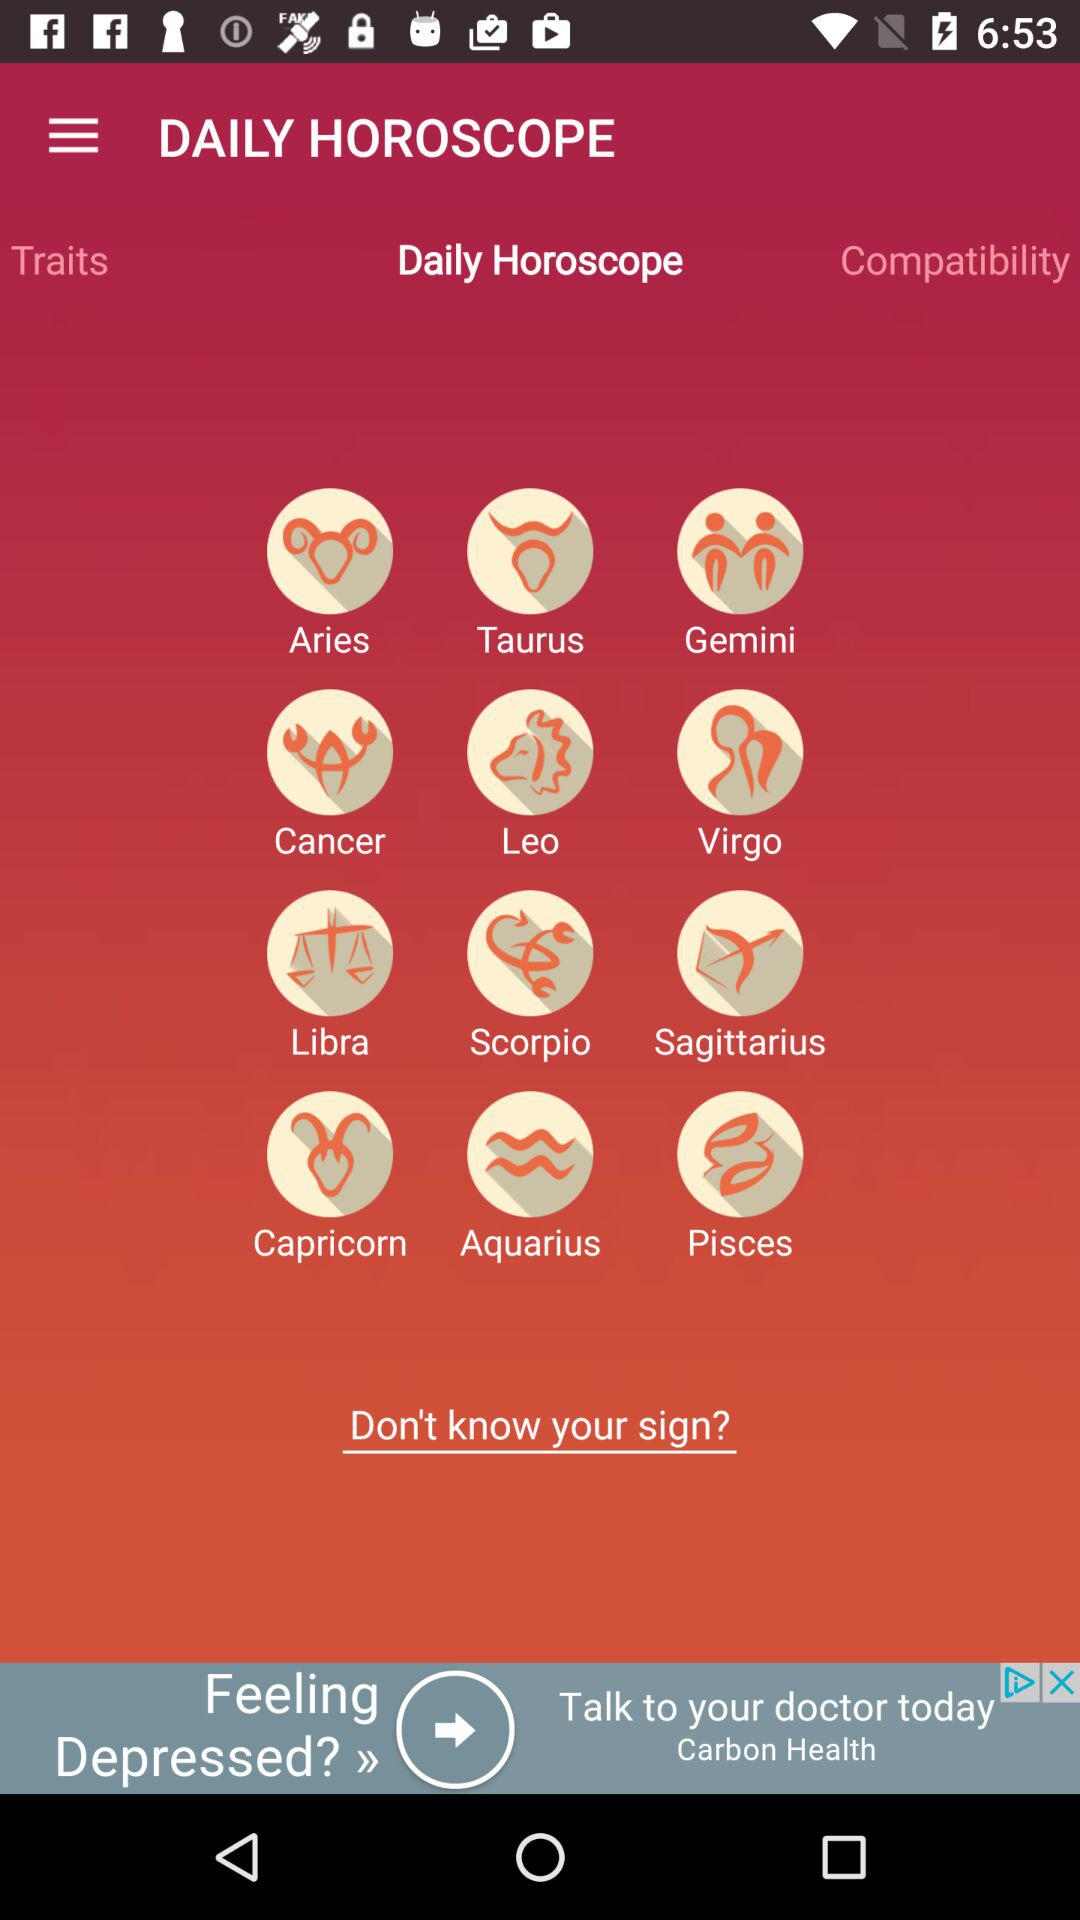Which is the selected tab? The selected tab is "Daily Horoscope". 